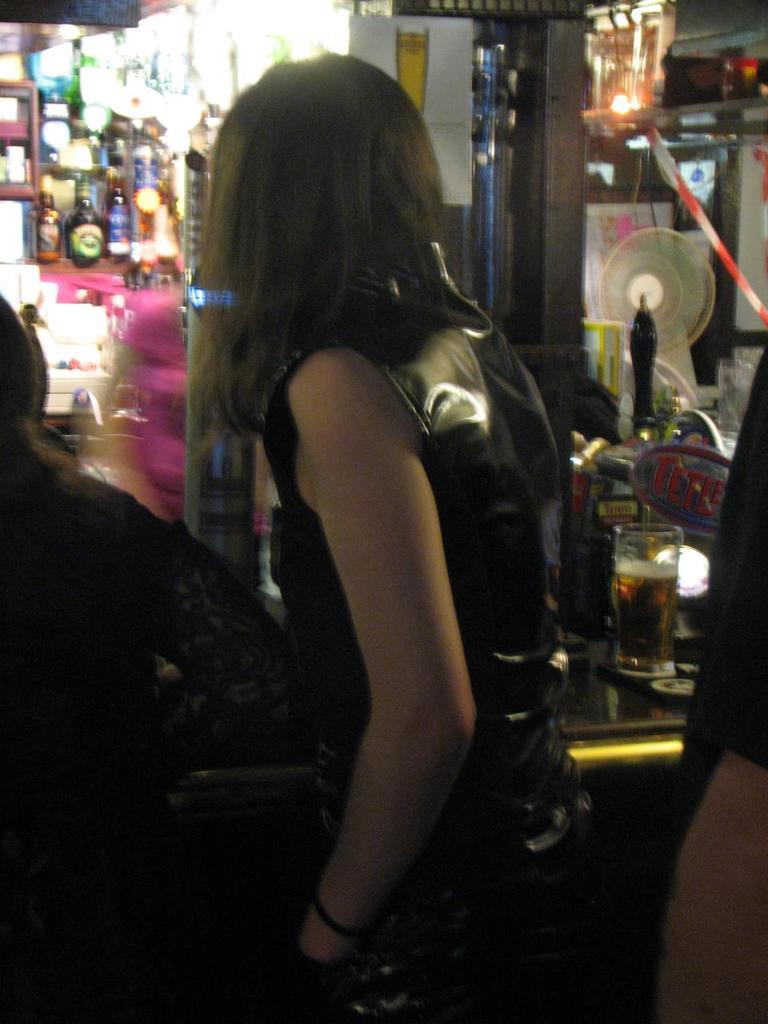How many people are present in the image? There are three people standing in the image. Can you describe one of the individuals in the image? There is a woman standing in the image. What is the woman holding in the image? There is a glass with a drink in the image. What type of storage can be seen in the image? There are bottles in racks in the image. What type of lighting is present in the image? There are lights in the image. What type of air circulation device is present in the image? There is a fan in the image. What type of decoration is present in the image? There is a poster in the image. Can you describe any unspecified objects in the image? There are some unspecified objects in the image. What type of leaf is falling from the sky in the image? There are no leaves or clouds present in the image, as it is an indoor setting with a fan and lights. 